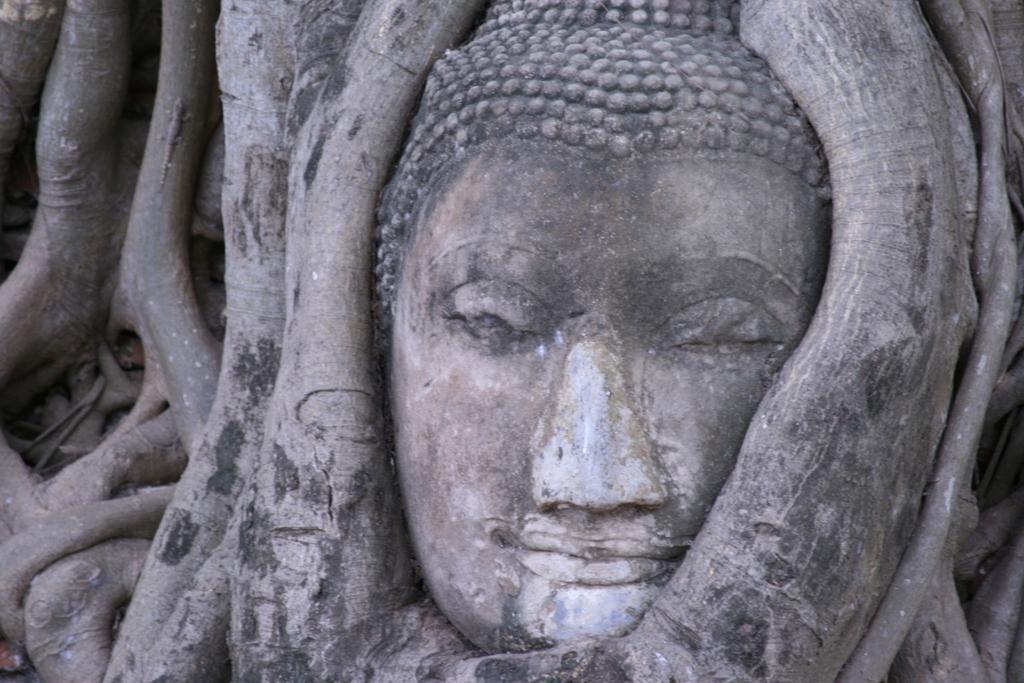Could you give a brief overview of what you see in this image? In this image we can see a sculpture in a tree. 